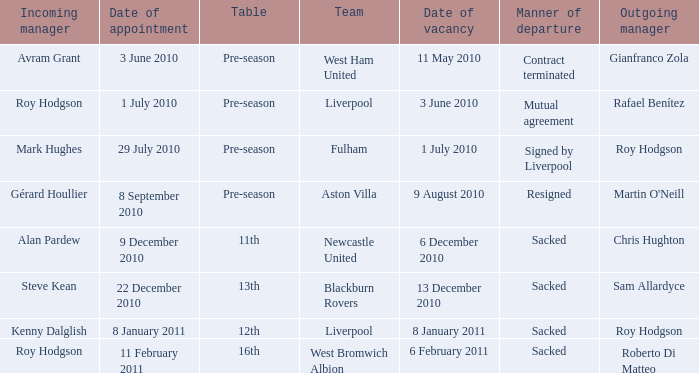What was the date of appointment for incoming manager Roy Hodgson and the team is Liverpool? 1 July 2010. 